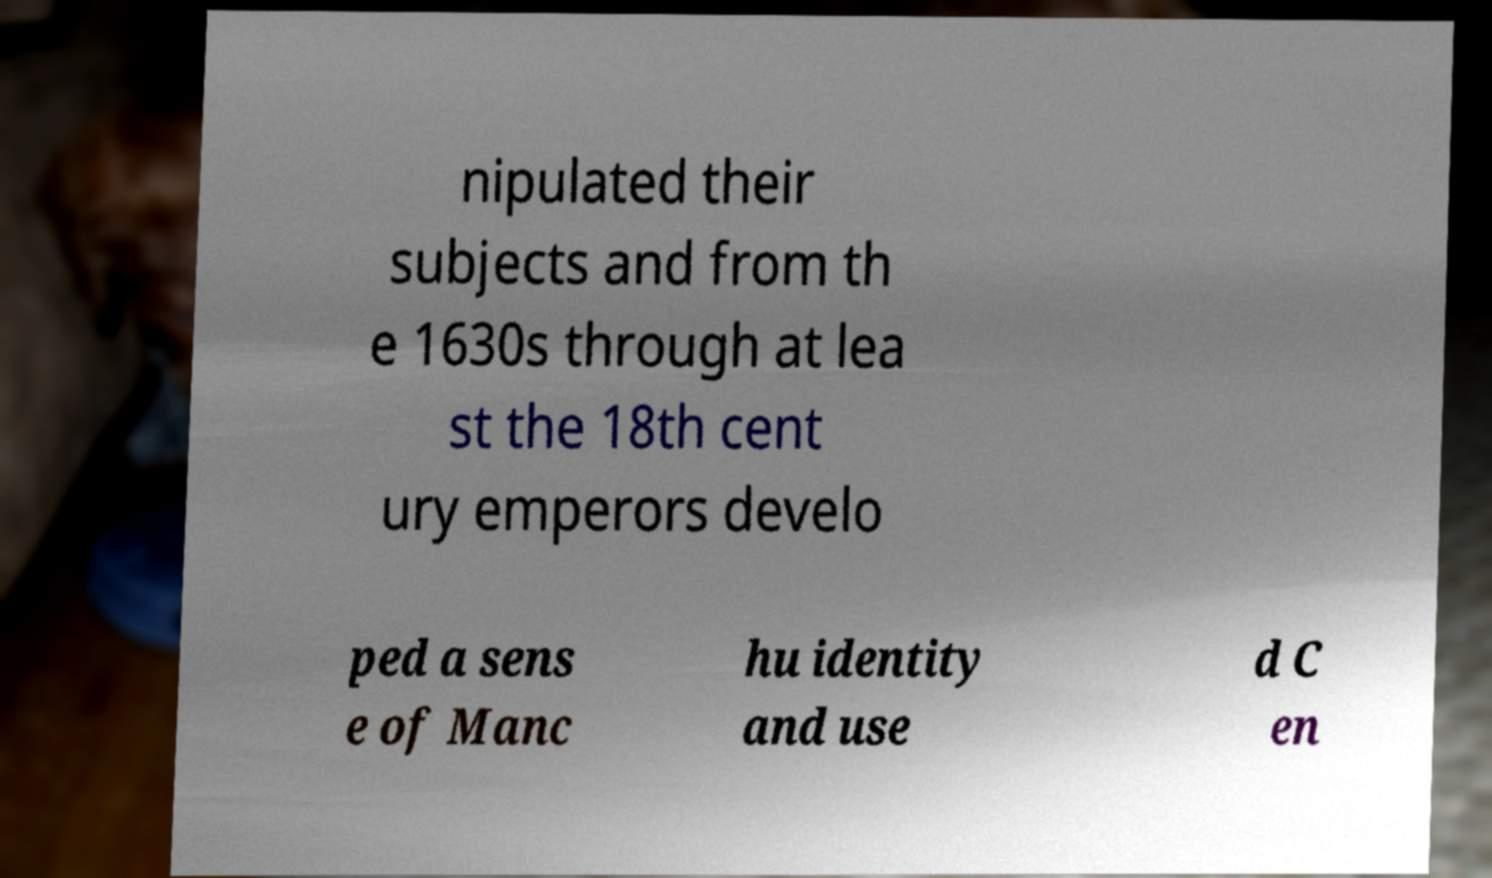Can you accurately transcribe the text from the provided image for me? nipulated their subjects and from th e 1630s through at lea st the 18th cent ury emperors develo ped a sens e of Manc hu identity and use d C en 